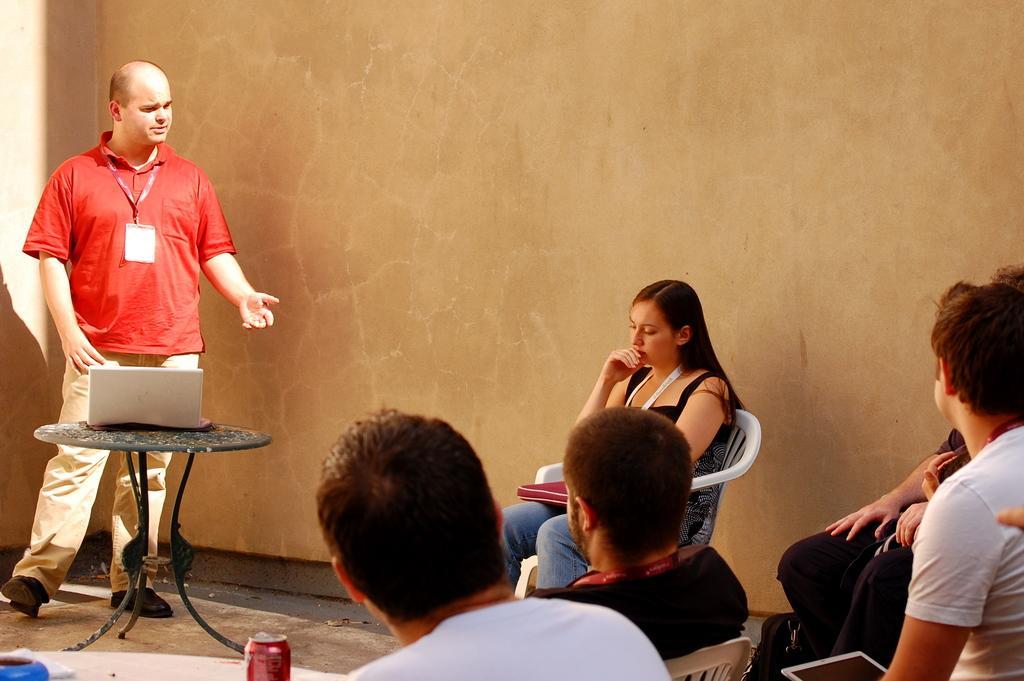Could you give a brief overview of what you see in this image? Here we can can see one man wearing red color t shirt standing and talking. This is a laptop on the table. We can see few persons sitting on chairs near to this man. This is a tin. 